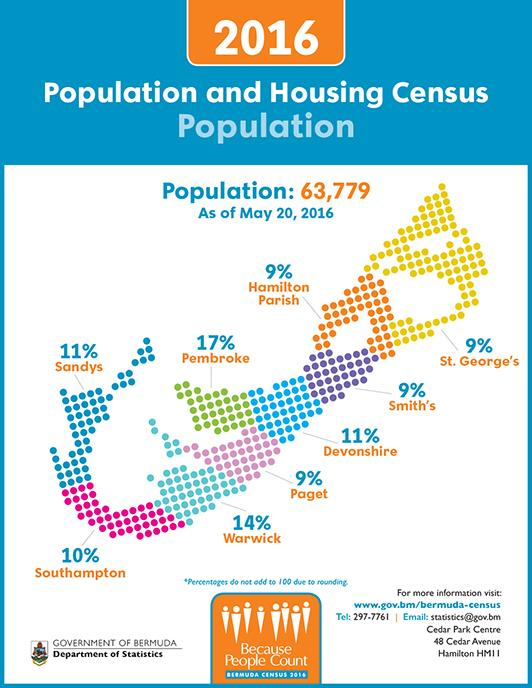Indicate a few pertinent items in this graphic. Bermuda has nine provinces or states. On May 20, 2016, the province/state of Pembroke in Bermuda had the highest percentage of housing. On May 20, 2016, the province/state of Warwick in Bermuda had the second-highest housing percentage, according to available data. 